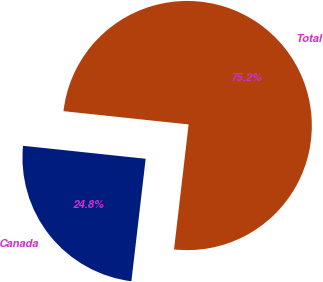Convert chart to OTSL. <chart><loc_0><loc_0><loc_500><loc_500><pie_chart><fcel>Canada<fcel>Total<nl><fcel>24.83%<fcel>75.17%<nl></chart> 